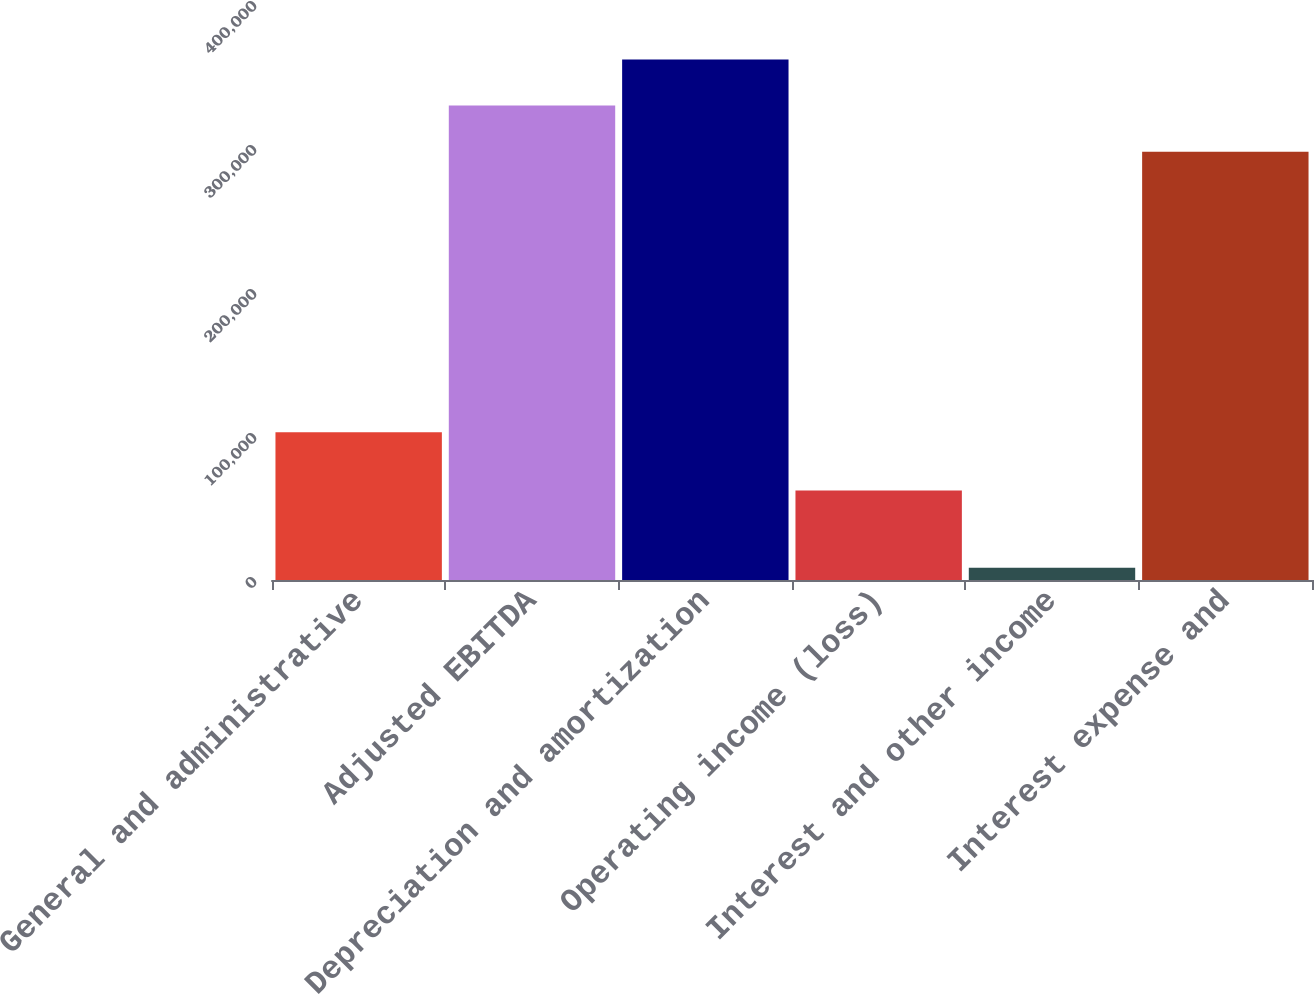Convert chart to OTSL. <chart><loc_0><loc_0><loc_500><loc_500><bar_chart><fcel>General and administrative<fcel>Adjusted EBITDA<fcel>Depreciation and amortization<fcel>Operating income (loss)<fcel>Interest and other income<fcel>Interest expense and<nl><fcel>102539<fcel>329438<fcel>361433<fcel>62099<fcel>8548<fcel>297444<nl></chart> 